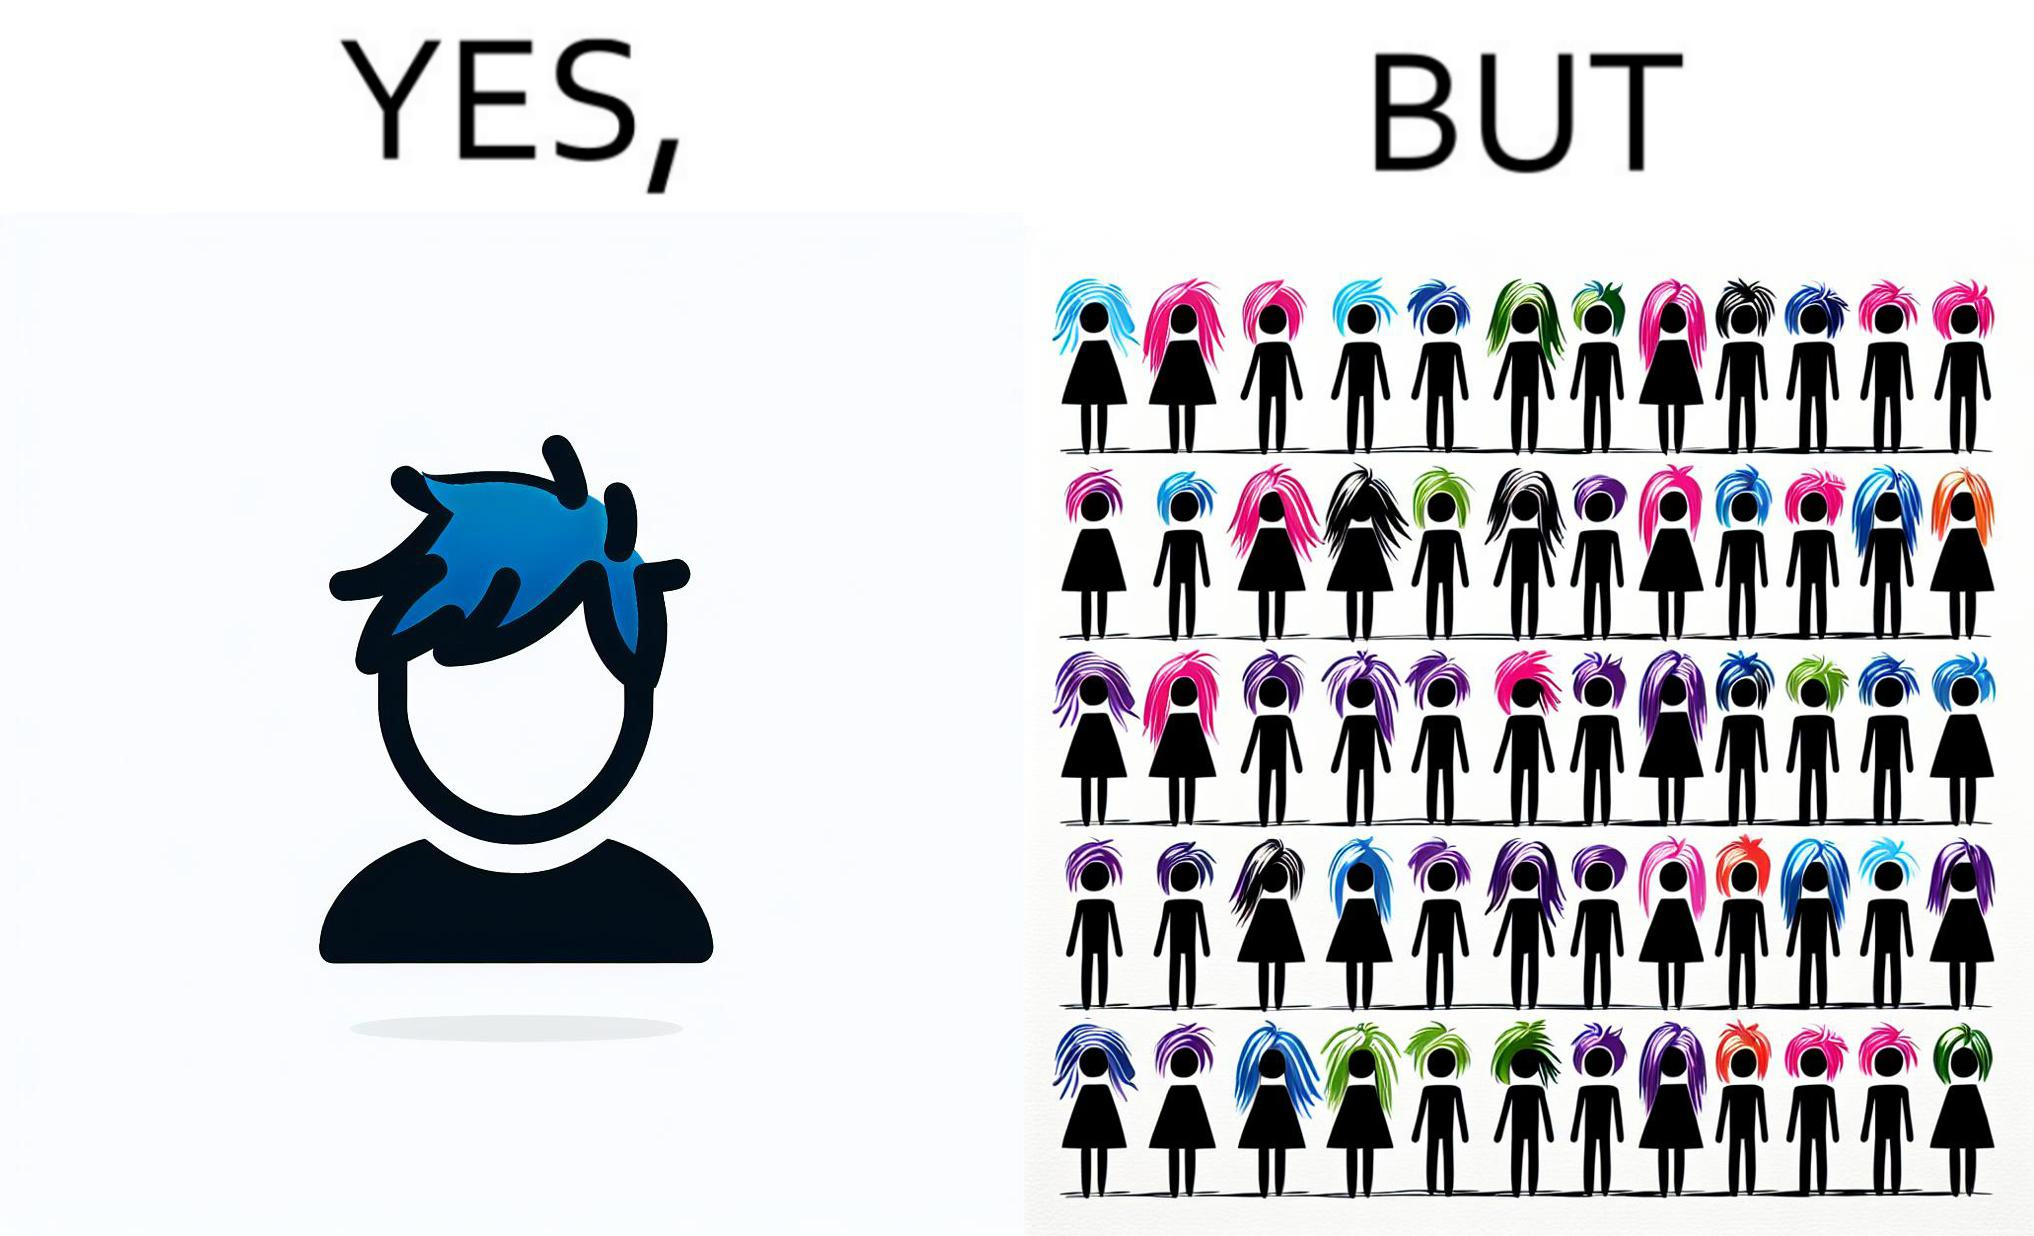What does this image depict? The image is funny, as one person with a hair dyed blue seems to symbolize that the person is going against the grain, however, when we zoom out, the group of people have hair dyed in several, different colors, showing that, dyeing hair is the new normal. 